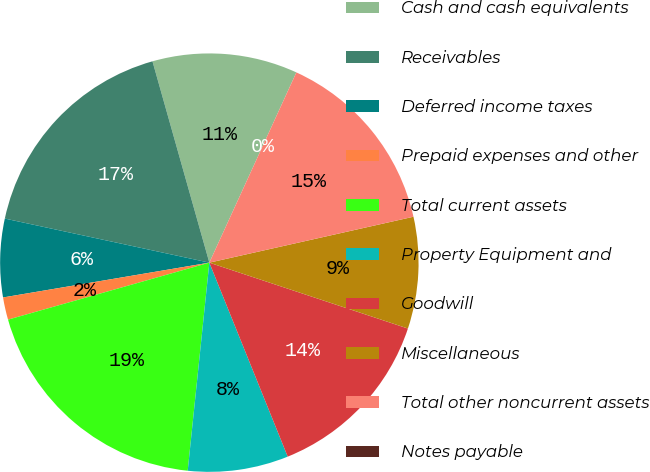Convert chart. <chart><loc_0><loc_0><loc_500><loc_500><pie_chart><fcel>Cash and cash equivalents<fcel>Receivables<fcel>Deferred income taxes<fcel>Prepaid expenses and other<fcel>Total current assets<fcel>Property Equipment and<fcel>Goodwill<fcel>Miscellaneous<fcel>Total other noncurrent assets<fcel>Notes payable<nl><fcel>11.21%<fcel>17.24%<fcel>6.04%<fcel>1.73%<fcel>18.96%<fcel>7.76%<fcel>13.79%<fcel>8.62%<fcel>14.65%<fcel>0.0%<nl></chart> 